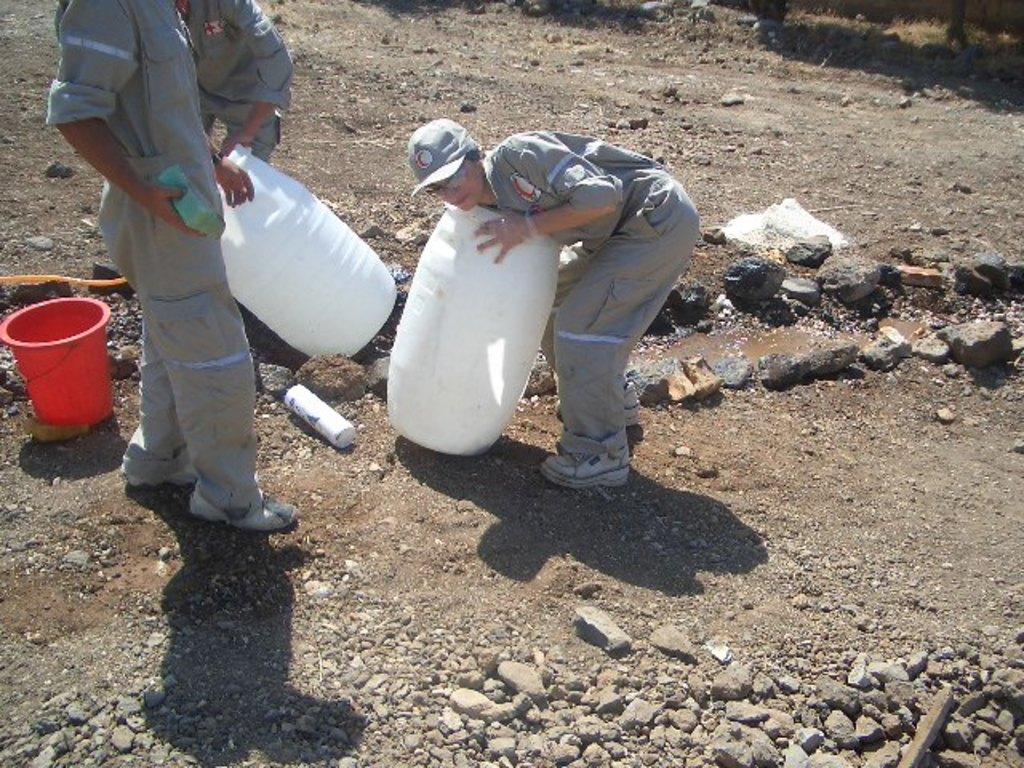Who or what is present in the image? There are people in the image. What objects can be seen in the image? There are containers and a bucket in the image. What is at the bottom of the image? There are stones at the bottom of the image. What is a person holding in the image? A person's hand is holding a sponge in the image. What type of dog can be seen sitting on the container in the image? There is no dog present in the image; it only features people, containers, a bucket, stones, and a person holding a sponge. 